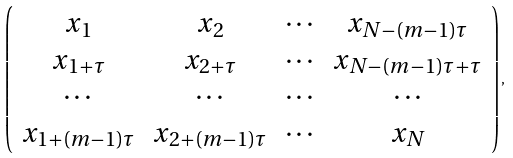<formula> <loc_0><loc_0><loc_500><loc_500>\left ( \begin{array} { c c c c } x _ { 1 } & x _ { 2 } & \cdots & x _ { N - ( m - 1 ) \tau } \\ x _ { 1 + \tau } & x _ { 2 + \tau } & \cdots & x _ { N - ( m - 1 ) \tau + \tau } \\ \cdots & \cdots & \cdots & \cdots \\ x _ { 1 + ( m - 1 ) \tau } & x _ { 2 + ( m - 1 ) \tau } & \cdots & x _ { N } \\ \end{array} \right ) ,</formula> 